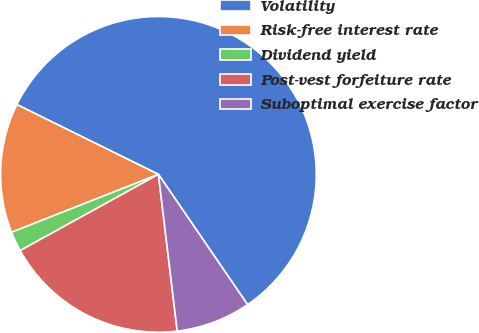Convert chart to OTSL. <chart><loc_0><loc_0><loc_500><loc_500><pie_chart><fcel>Volatility<fcel>Risk-free interest rate<fcel>Dividend yield<fcel>Post-vest forfeiture rate<fcel>Suboptimal exercise factor<nl><fcel>58.16%<fcel>13.27%<fcel>2.04%<fcel>18.88%<fcel>7.65%<nl></chart> 